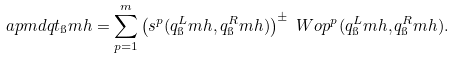<formula> <loc_0><loc_0><loc_500><loc_500>\ a p m d q t _ { \i } m h & = \sum _ { p = 1 } ^ { m } \left ( s ^ { p } ( q ^ { L } _ { \i } m h , q ^ { R } _ { \i } m h ) \right ) ^ { \pm } \ W o p ^ { p } ( q ^ { L } _ { \i } m h , q ^ { R } _ { \i } m h ) .</formula> 